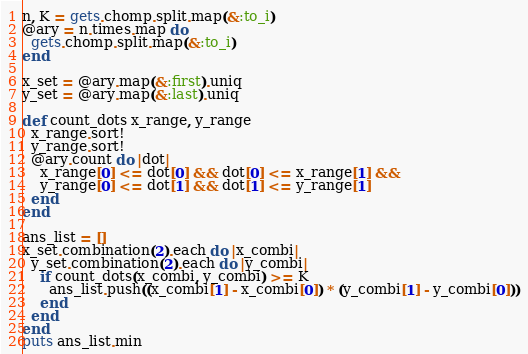Convert code to text. <code><loc_0><loc_0><loc_500><loc_500><_Ruby_>n, K = gets.chomp.split.map(&:to_i)
@ary = n.times.map do
  gets.chomp.split.map(&:to_i)
end

x_set = @ary.map(&:first).uniq
y_set = @ary.map(&:last).uniq

def count_dots x_range, y_range
  x_range.sort!
  y_range.sort!
  @ary.count do |dot|
    x_range[0] <= dot[0] && dot[0] <= x_range[1] &&
    y_range[0] <= dot[1] && dot[1] <= y_range[1]
  end
end

ans_list = []
x_set.combination(2).each do |x_combi|
  y_set.combination(2).each do |y_combi|
    if count_dots(x_combi, y_combi) >= K
      ans_list.push((x_combi[1] - x_combi[0]) * (y_combi[1] - y_combi[0]))
    end
  end
end
puts ans_list.min</code> 